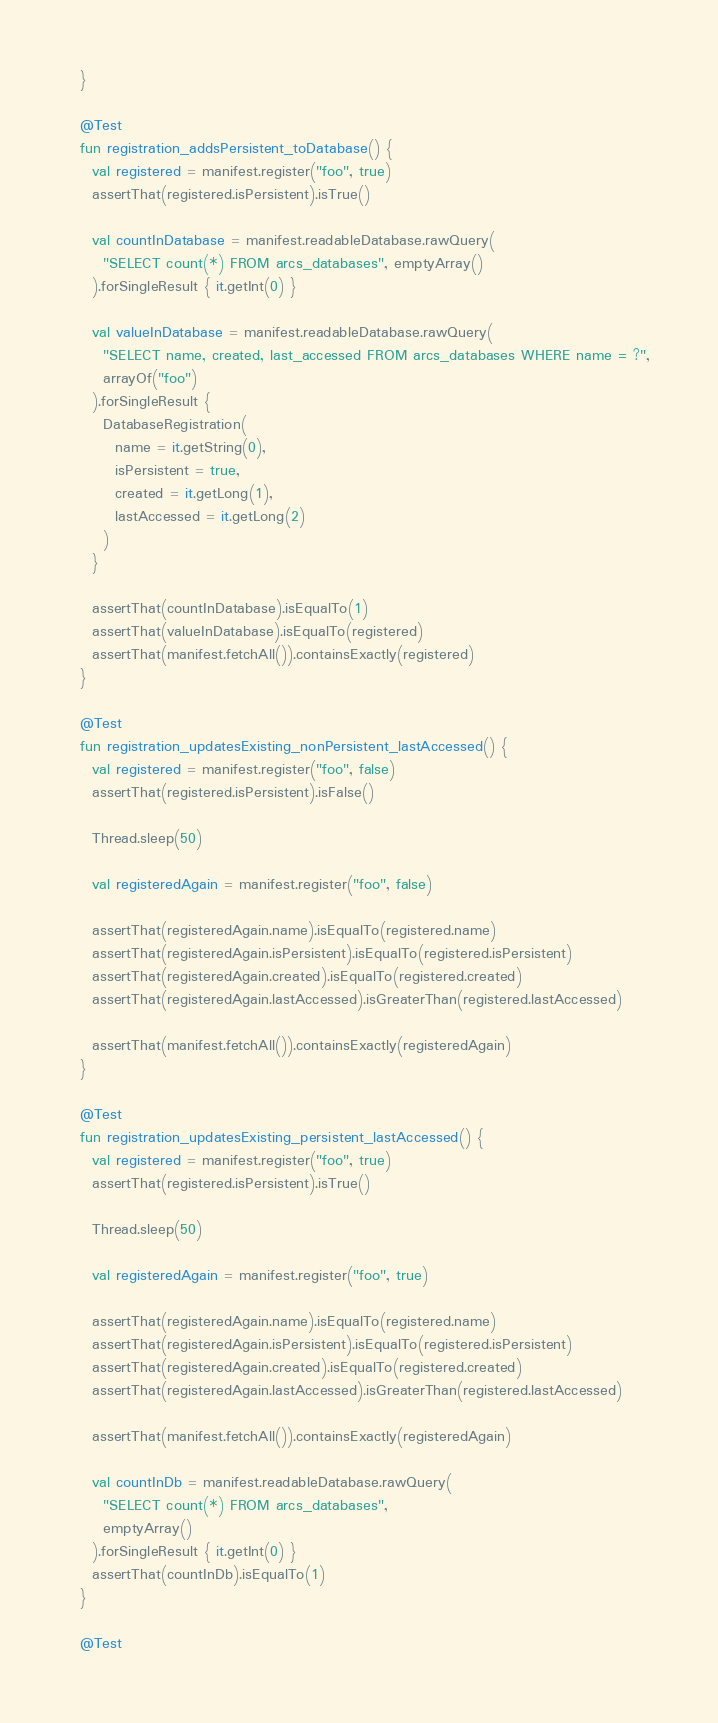Convert code to text. <code><loc_0><loc_0><loc_500><loc_500><_Kotlin_>  }

  @Test
  fun registration_addsPersistent_toDatabase() {
    val registered = manifest.register("foo", true)
    assertThat(registered.isPersistent).isTrue()

    val countInDatabase = manifest.readableDatabase.rawQuery(
      "SELECT count(*) FROM arcs_databases", emptyArray()
    ).forSingleResult { it.getInt(0) }

    val valueInDatabase = manifest.readableDatabase.rawQuery(
      "SELECT name, created, last_accessed FROM arcs_databases WHERE name = ?",
      arrayOf("foo")
    ).forSingleResult {
      DatabaseRegistration(
        name = it.getString(0),
        isPersistent = true,
        created = it.getLong(1),
        lastAccessed = it.getLong(2)
      )
    }

    assertThat(countInDatabase).isEqualTo(1)
    assertThat(valueInDatabase).isEqualTo(registered)
    assertThat(manifest.fetchAll()).containsExactly(registered)
  }

  @Test
  fun registration_updatesExisting_nonPersistent_lastAccessed() {
    val registered = manifest.register("foo", false)
    assertThat(registered.isPersistent).isFalse()

    Thread.sleep(50)

    val registeredAgain = manifest.register("foo", false)

    assertThat(registeredAgain.name).isEqualTo(registered.name)
    assertThat(registeredAgain.isPersistent).isEqualTo(registered.isPersistent)
    assertThat(registeredAgain.created).isEqualTo(registered.created)
    assertThat(registeredAgain.lastAccessed).isGreaterThan(registered.lastAccessed)

    assertThat(manifest.fetchAll()).containsExactly(registeredAgain)
  }

  @Test
  fun registration_updatesExisting_persistent_lastAccessed() {
    val registered = manifest.register("foo", true)
    assertThat(registered.isPersistent).isTrue()

    Thread.sleep(50)

    val registeredAgain = manifest.register("foo", true)

    assertThat(registeredAgain.name).isEqualTo(registered.name)
    assertThat(registeredAgain.isPersistent).isEqualTo(registered.isPersistent)
    assertThat(registeredAgain.created).isEqualTo(registered.created)
    assertThat(registeredAgain.lastAccessed).isGreaterThan(registered.lastAccessed)

    assertThat(manifest.fetchAll()).containsExactly(registeredAgain)

    val countInDb = manifest.readableDatabase.rawQuery(
      "SELECT count(*) FROM arcs_databases",
      emptyArray()
    ).forSingleResult { it.getInt(0) }
    assertThat(countInDb).isEqualTo(1)
  }

  @Test</code> 